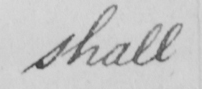Please transcribe the handwritten text in this image. shall 